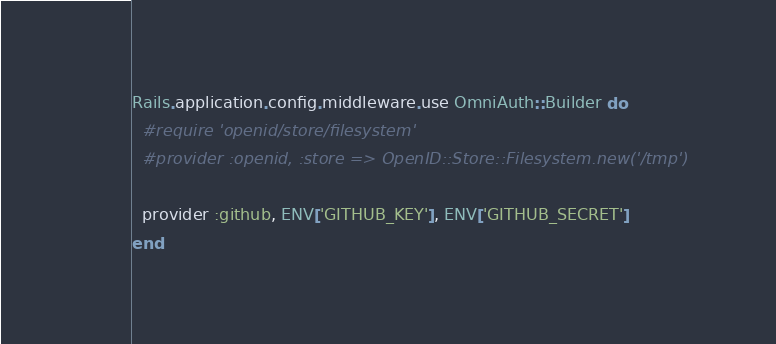<code> <loc_0><loc_0><loc_500><loc_500><_Ruby_>Rails.application.config.middleware.use OmniAuth::Builder do
  #require 'openid/store/filesystem' 
  #provider :openid, :store => OpenID::Store::Filesystem.new('/tmp')

  provider :github, ENV['GITHUB_KEY'], ENV['GITHUB_SECRET']
end

</code> 